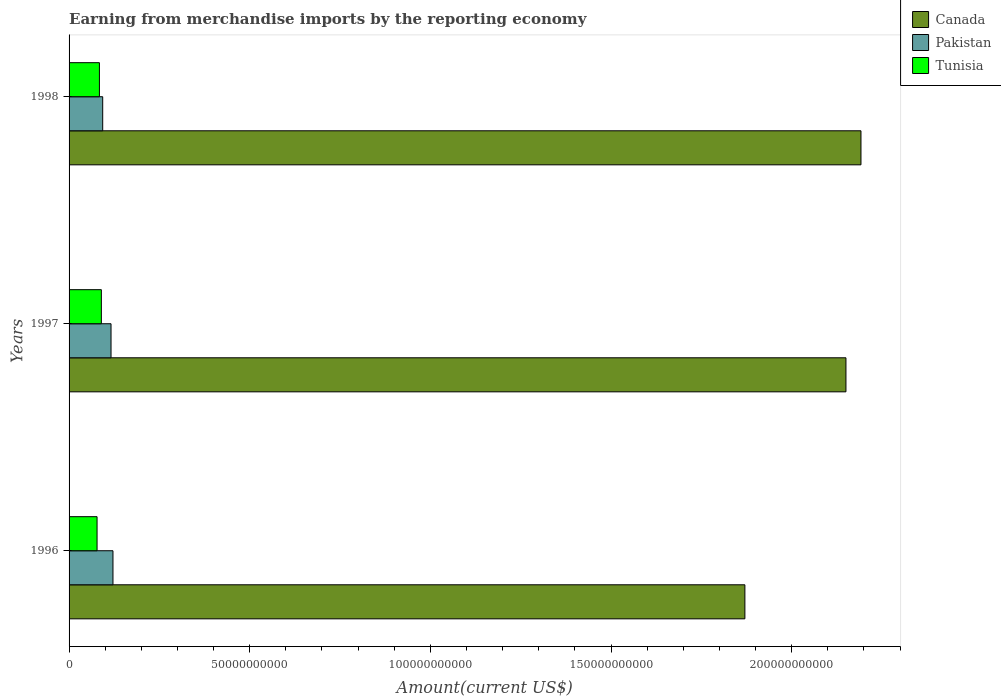Are the number of bars per tick equal to the number of legend labels?
Offer a very short reply. Yes. How many bars are there on the 3rd tick from the top?
Offer a very short reply. 3. How many bars are there on the 3rd tick from the bottom?
Ensure brevity in your answer.  3. What is the label of the 2nd group of bars from the top?
Provide a succinct answer. 1997. In how many cases, is the number of bars for a given year not equal to the number of legend labels?
Your answer should be compact. 0. What is the amount earned from merchandise imports in Pakistan in 1997?
Give a very brief answer. 1.16e+1. Across all years, what is the maximum amount earned from merchandise imports in Pakistan?
Keep it short and to the point. 1.21e+1. Across all years, what is the minimum amount earned from merchandise imports in Canada?
Ensure brevity in your answer.  1.87e+11. In which year was the amount earned from merchandise imports in Pakistan maximum?
Provide a short and direct response. 1996. What is the total amount earned from merchandise imports in Tunisia in the graph?
Offer a very short reply. 2.51e+1. What is the difference between the amount earned from merchandise imports in Canada in 1997 and that in 1998?
Give a very brief answer. -4.16e+09. What is the difference between the amount earned from merchandise imports in Canada in 1996 and the amount earned from merchandise imports in Tunisia in 1998?
Your answer should be compact. 1.79e+11. What is the average amount earned from merchandise imports in Tunisia per year?
Your answer should be compact. 8.36e+09. In the year 1998, what is the difference between the amount earned from merchandise imports in Tunisia and amount earned from merchandise imports in Pakistan?
Keep it short and to the point. -9.06e+08. What is the ratio of the amount earned from merchandise imports in Pakistan in 1997 to that in 1998?
Keep it short and to the point. 1.25. Is the amount earned from merchandise imports in Tunisia in 1996 less than that in 1997?
Offer a very short reply. Yes. What is the difference between the highest and the second highest amount earned from merchandise imports in Canada?
Offer a terse response. 4.16e+09. What is the difference between the highest and the lowest amount earned from merchandise imports in Pakistan?
Ensure brevity in your answer.  2.84e+09. Is it the case that in every year, the sum of the amount earned from merchandise imports in Tunisia and amount earned from merchandise imports in Canada is greater than the amount earned from merchandise imports in Pakistan?
Your answer should be very brief. Yes. Are all the bars in the graph horizontal?
Offer a terse response. Yes. Are the values on the major ticks of X-axis written in scientific E-notation?
Offer a very short reply. No. Does the graph contain any zero values?
Provide a short and direct response. No. Does the graph contain grids?
Provide a succinct answer. No. Where does the legend appear in the graph?
Ensure brevity in your answer.  Top right. How many legend labels are there?
Your answer should be compact. 3. How are the legend labels stacked?
Your response must be concise. Vertical. What is the title of the graph?
Offer a terse response. Earning from merchandise imports by the reporting economy. What is the label or title of the X-axis?
Your response must be concise. Amount(current US$). What is the Amount(current US$) of Canada in 1996?
Your answer should be compact. 1.87e+11. What is the Amount(current US$) in Pakistan in 1996?
Ensure brevity in your answer.  1.21e+1. What is the Amount(current US$) of Tunisia in 1996?
Your answer should be compact. 7.75e+09. What is the Amount(current US$) in Canada in 1997?
Offer a terse response. 2.15e+11. What is the Amount(current US$) of Pakistan in 1997?
Give a very brief answer. 1.16e+1. What is the Amount(current US$) of Tunisia in 1997?
Your answer should be very brief. 8.93e+09. What is the Amount(current US$) of Canada in 1998?
Offer a very short reply. 2.19e+11. What is the Amount(current US$) of Pakistan in 1998?
Make the answer very short. 9.31e+09. What is the Amount(current US$) of Tunisia in 1998?
Offer a terse response. 8.40e+09. Across all years, what is the maximum Amount(current US$) in Canada?
Offer a terse response. 2.19e+11. Across all years, what is the maximum Amount(current US$) of Pakistan?
Your response must be concise. 1.21e+1. Across all years, what is the maximum Amount(current US$) of Tunisia?
Keep it short and to the point. 8.93e+09. Across all years, what is the minimum Amount(current US$) in Canada?
Offer a very short reply. 1.87e+11. Across all years, what is the minimum Amount(current US$) in Pakistan?
Offer a terse response. 9.31e+09. Across all years, what is the minimum Amount(current US$) in Tunisia?
Your answer should be compact. 7.75e+09. What is the total Amount(current US$) in Canada in the graph?
Your answer should be very brief. 6.21e+11. What is the total Amount(current US$) of Pakistan in the graph?
Provide a short and direct response. 3.31e+1. What is the total Amount(current US$) in Tunisia in the graph?
Provide a short and direct response. 2.51e+1. What is the difference between the Amount(current US$) of Canada in 1996 and that in 1997?
Offer a terse response. -2.80e+1. What is the difference between the Amount(current US$) in Pakistan in 1996 and that in 1997?
Offer a very short reply. 5.38e+08. What is the difference between the Amount(current US$) of Tunisia in 1996 and that in 1997?
Provide a succinct answer. -1.19e+09. What is the difference between the Amount(current US$) of Canada in 1996 and that in 1998?
Give a very brief answer. -3.21e+1. What is the difference between the Amount(current US$) in Pakistan in 1996 and that in 1998?
Keep it short and to the point. 2.84e+09. What is the difference between the Amount(current US$) of Tunisia in 1996 and that in 1998?
Your response must be concise. -6.54e+08. What is the difference between the Amount(current US$) in Canada in 1997 and that in 1998?
Provide a succinct answer. -4.16e+09. What is the difference between the Amount(current US$) in Pakistan in 1997 and that in 1998?
Your answer should be very brief. 2.30e+09. What is the difference between the Amount(current US$) in Tunisia in 1997 and that in 1998?
Your answer should be compact. 5.32e+08. What is the difference between the Amount(current US$) of Canada in 1996 and the Amount(current US$) of Pakistan in 1997?
Provide a short and direct response. 1.75e+11. What is the difference between the Amount(current US$) of Canada in 1996 and the Amount(current US$) of Tunisia in 1997?
Provide a succinct answer. 1.78e+11. What is the difference between the Amount(current US$) in Pakistan in 1996 and the Amount(current US$) in Tunisia in 1997?
Your answer should be very brief. 3.22e+09. What is the difference between the Amount(current US$) in Canada in 1996 and the Amount(current US$) in Pakistan in 1998?
Provide a succinct answer. 1.78e+11. What is the difference between the Amount(current US$) of Canada in 1996 and the Amount(current US$) of Tunisia in 1998?
Offer a very short reply. 1.79e+11. What is the difference between the Amount(current US$) in Pakistan in 1996 and the Amount(current US$) in Tunisia in 1998?
Your response must be concise. 3.75e+09. What is the difference between the Amount(current US$) in Canada in 1997 and the Amount(current US$) in Pakistan in 1998?
Your response must be concise. 2.06e+11. What is the difference between the Amount(current US$) of Canada in 1997 and the Amount(current US$) of Tunisia in 1998?
Your response must be concise. 2.07e+11. What is the difference between the Amount(current US$) of Pakistan in 1997 and the Amount(current US$) of Tunisia in 1998?
Your response must be concise. 3.21e+09. What is the average Amount(current US$) in Canada per year?
Ensure brevity in your answer.  2.07e+11. What is the average Amount(current US$) in Pakistan per year?
Offer a terse response. 1.10e+1. What is the average Amount(current US$) of Tunisia per year?
Offer a terse response. 8.36e+09. In the year 1996, what is the difference between the Amount(current US$) in Canada and Amount(current US$) in Pakistan?
Keep it short and to the point. 1.75e+11. In the year 1996, what is the difference between the Amount(current US$) of Canada and Amount(current US$) of Tunisia?
Offer a very short reply. 1.79e+11. In the year 1996, what is the difference between the Amount(current US$) in Pakistan and Amount(current US$) in Tunisia?
Give a very brief answer. 4.40e+09. In the year 1997, what is the difference between the Amount(current US$) of Canada and Amount(current US$) of Pakistan?
Offer a very short reply. 2.03e+11. In the year 1997, what is the difference between the Amount(current US$) of Canada and Amount(current US$) of Tunisia?
Offer a very short reply. 2.06e+11. In the year 1997, what is the difference between the Amount(current US$) of Pakistan and Amount(current US$) of Tunisia?
Your answer should be very brief. 2.68e+09. In the year 1998, what is the difference between the Amount(current US$) in Canada and Amount(current US$) in Pakistan?
Provide a short and direct response. 2.10e+11. In the year 1998, what is the difference between the Amount(current US$) in Canada and Amount(current US$) in Tunisia?
Provide a succinct answer. 2.11e+11. In the year 1998, what is the difference between the Amount(current US$) of Pakistan and Amount(current US$) of Tunisia?
Offer a terse response. 9.06e+08. What is the ratio of the Amount(current US$) of Canada in 1996 to that in 1997?
Offer a very short reply. 0.87. What is the ratio of the Amount(current US$) in Pakistan in 1996 to that in 1997?
Ensure brevity in your answer.  1.05. What is the ratio of the Amount(current US$) of Tunisia in 1996 to that in 1997?
Your answer should be compact. 0.87. What is the ratio of the Amount(current US$) in Canada in 1996 to that in 1998?
Provide a succinct answer. 0.85. What is the ratio of the Amount(current US$) in Pakistan in 1996 to that in 1998?
Offer a very short reply. 1.31. What is the ratio of the Amount(current US$) in Tunisia in 1996 to that in 1998?
Your response must be concise. 0.92. What is the ratio of the Amount(current US$) of Canada in 1997 to that in 1998?
Provide a succinct answer. 0.98. What is the ratio of the Amount(current US$) in Pakistan in 1997 to that in 1998?
Keep it short and to the point. 1.25. What is the ratio of the Amount(current US$) in Tunisia in 1997 to that in 1998?
Your response must be concise. 1.06. What is the difference between the highest and the second highest Amount(current US$) of Canada?
Make the answer very short. 4.16e+09. What is the difference between the highest and the second highest Amount(current US$) in Pakistan?
Your response must be concise. 5.38e+08. What is the difference between the highest and the second highest Amount(current US$) in Tunisia?
Your answer should be compact. 5.32e+08. What is the difference between the highest and the lowest Amount(current US$) of Canada?
Give a very brief answer. 3.21e+1. What is the difference between the highest and the lowest Amount(current US$) of Pakistan?
Provide a short and direct response. 2.84e+09. What is the difference between the highest and the lowest Amount(current US$) of Tunisia?
Offer a very short reply. 1.19e+09. 